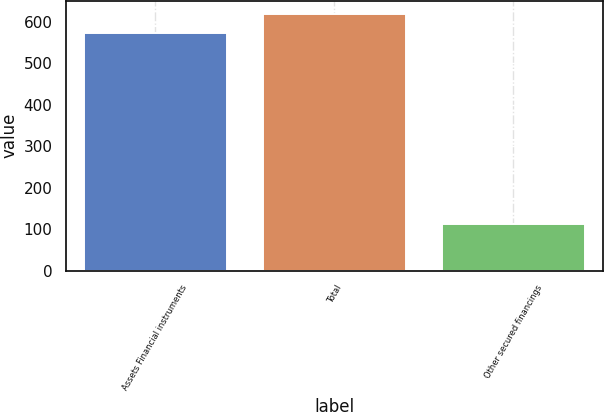Convert chart to OTSL. <chart><loc_0><loc_0><loc_500><loc_500><bar_chart><fcel>Assets Financial instruments<fcel>Total<fcel>Other secured financings<nl><fcel>572<fcel>619.4<fcel>113<nl></chart> 